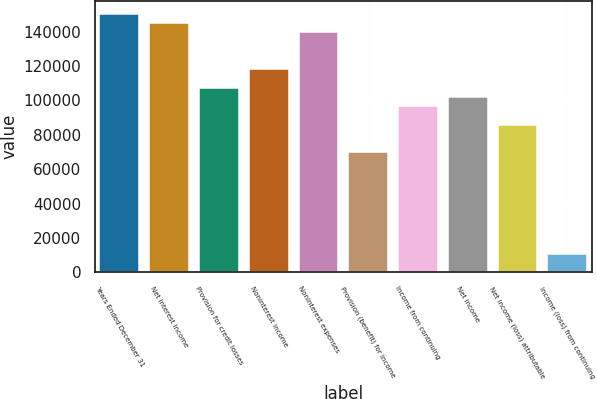Convert chart to OTSL. <chart><loc_0><loc_0><loc_500><loc_500><bar_chart><fcel>Years Ended December 31<fcel>Net interest income<fcel>Provision for credit losses<fcel>Noninterest income<fcel>Noninterest expenses<fcel>Provision (benefit) for income<fcel>Income from continuing<fcel>Net income<fcel>Net income (loss) attributable<fcel>Income (loss) from continuing<nl><fcel>150267<fcel>144901<fcel>107334<fcel>118067<fcel>139534<fcel>69767.1<fcel>96600.5<fcel>101967<fcel>85867.1<fcel>10733.6<nl></chart> 